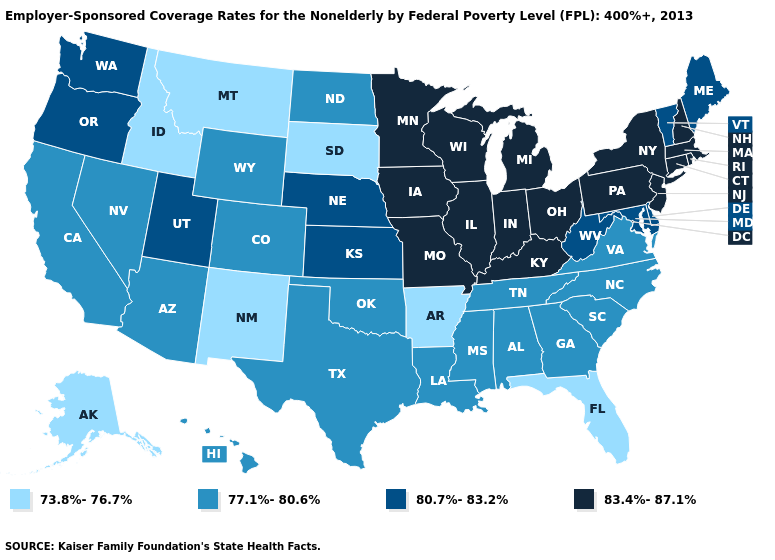Name the states that have a value in the range 80.7%-83.2%?
Give a very brief answer. Delaware, Kansas, Maine, Maryland, Nebraska, Oregon, Utah, Vermont, Washington, West Virginia. Name the states that have a value in the range 77.1%-80.6%?
Keep it brief. Alabama, Arizona, California, Colorado, Georgia, Hawaii, Louisiana, Mississippi, Nevada, North Carolina, North Dakota, Oklahoma, South Carolina, Tennessee, Texas, Virginia, Wyoming. What is the value of Iowa?
Be succinct. 83.4%-87.1%. Does Nebraska have the highest value in the MidWest?
Answer briefly. No. Does South Dakota have the lowest value in the MidWest?
Write a very short answer. Yes. What is the value of South Dakota?
Short answer required. 73.8%-76.7%. What is the value of Montana?
Write a very short answer. 73.8%-76.7%. What is the highest value in the South ?
Give a very brief answer. 83.4%-87.1%. What is the value of Kansas?
Concise answer only. 80.7%-83.2%. Does New Hampshire have the highest value in the USA?
Give a very brief answer. Yes. What is the lowest value in the USA?
Keep it brief. 73.8%-76.7%. Does the first symbol in the legend represent the smallest category?
Give a very brief answer. Yes. Does Nebraska have the lowest value in the MidWest?
Write a very short answer. No. What is the lowest value in states that border Pennsylvania?
Give a very brief answer. 80.7%-83.2%. 